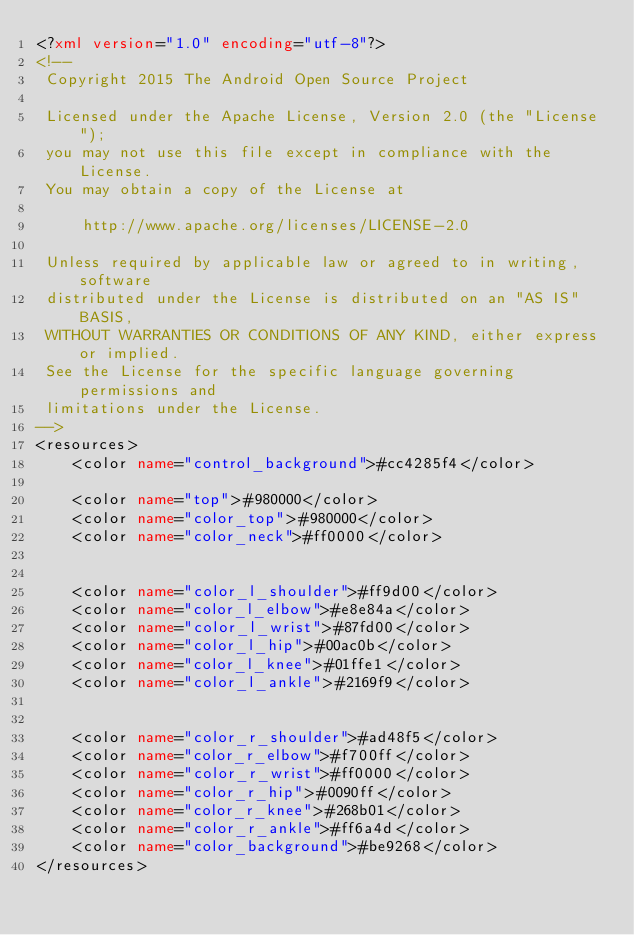<code> <loc_0><loc_0><loc_500><loc_500><_XML_><?xml version="1.0" encoding="utf-8"?>
<!--
 Copyright 2015 The Android Open Source Project

 Licensed under the Apache License, Version 2.0 (the "License");
 you may not use this file except in compliance with the License.
 You may obtain a copy of the License at

     http://www.apache.org/licenses/LICENSE-2.0

 Unless required by applicable law or agreed to in writing, software
 distributed under the License is distributed on an "AS IS" BASIS,
 WITHOUT WARRANTIES OR CONDITIONS OF ANY KIND, either express or implied.
 See the License for the specific language governing permissions and
 limitations under the License.
-->
<resources>
    <color name="control_background">#cc4285f4</color>

    <color name="top">#980000</color>
    <color name="color_top">#980000</color>
    <color name="color_neck">#ff0000</color>


    <color name="color_l_shoulder">#ff9d00</color>
    <color name="color_l_elbow">#e8e84a</color>
    <color name="color_l_wrist">#87fd00</color>
    <color name="color_l_hip">#00ac0b</color>
    <color name="color_l_knee">#01ffe1</color>
    <color name="color_l_ankle">#2169f9</color>


    <color name="color_r_shoulder">#ad48f5</color>
    <color name="color_r_elbow">#f700ff</color>
    <color name="color_r_wrist">#ff0000</color>
    <color name="color_r_hip">#0090ff</color>
    <color name="color_r_knee">#268b01</color>
    <color name="color_r_ankle">#ff6a4d</color>
    <color name="color_background">#be9268</color>
</resources>
</code> 